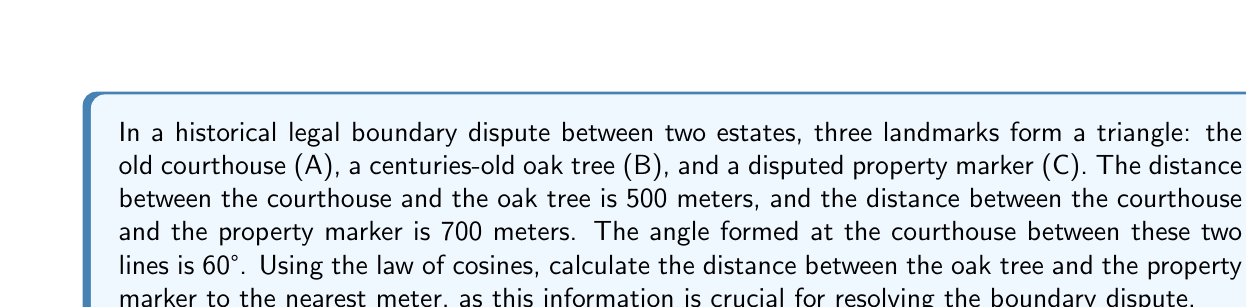What is the answer to this math problem? To solve this problem, we'll use the law of cosines. Let's define our variables:

$a$ = distance between B and C (oak tree to property marker, unknown)
$b$ = distance between A and C (courthouse to property marker, 700 meters)
$c$ = distance between A and B (courthouse to oak tree, 500 meters)
$\gamma$ = angle at A (courthouse, 60°)

The law of cosines states:

$$a^2 = b^2 + c^2 - 2bc \cos(\gamma)$$

Let's substitute our known values:

$$a^2 = 700^2 + 500^2 - 2(700)(500) \cos(60°)$$

Now, let's solve step-by-step:

1) First, calculate $\cos(60°)$:
   $\cos(60°) = \frac{1}{2}$

2) Substitute this value:
   $$a^2 = 700^2 + 500^2 - 2(700)(500) (\frac{1}{2})$$

3) Simplify:
   $$a^2 = 490,000 + 250,000 - 350,000$$
   $$a^2 = 390,000$$

4) Take the square root of both sides:
   $$a = \sqrt{390,000}$$

5) Calculate the final result:
   $$a \approx 624.50 \text{ meters}$$

6) Round to the nearest meter:
   $$a \approx 625 \text{ meters}$$

Therefore, the distance between the oak tree and the property marker is approximately 625 meters.
Answer: 625 meters 